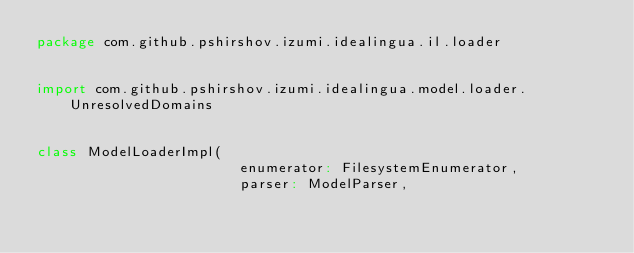Convert code to text. <code><loc_0><loc_0><loc_500><loc_500><_Scala_>package com.github.pshirshov.izumi.idealingua.il.loader


import com.github.pshirshov.izumi.idealingua.model.loader.UnresolvedDomains


class ModelLoaderImpl(
                        enumerator: FilesystemEnumerator,
                        parser: ModelParser,</code> 